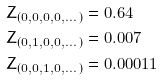Convert formula to latex. <formula><loc_0><loc_0><loc_500><loc_500>& Z _ { ( 0 , 0 , 0 , 0 , \dots ) } = 0 . 6 4 \\ & Z _ { ( 0 , 1 , 0 , 0 , \dots ) } = 0 . 0 0 7 \\ & Z _ { ( 0 , 0 , 1 , 0 , \dots ) } = 0 . 0 0 0 1 1 \\</formula> 